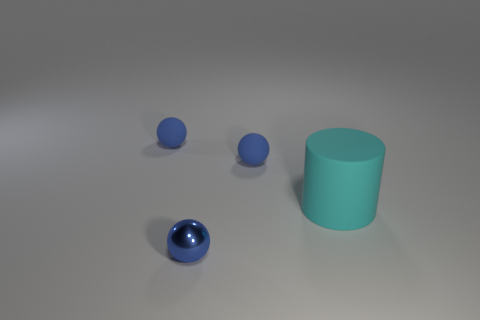Subtract all blue balls. How many were subtracted if there are1blue balls left? 2 Subtract all tiny blue matte balls. How many balls are left? 1 Add 1 cylinders. How many objects exist? 5 Add 3 blue shiny things. How many blue shiny things are left? 4 Add 1 tiny blue things. How many tiny blue things exist? 4 Subtract 0 red balls. How many objects are left? 4 Subtract all cylinders. How many objects are left? 3 Subtract all green cubes. Subtract all tiny objects. How many objects are left? 1 